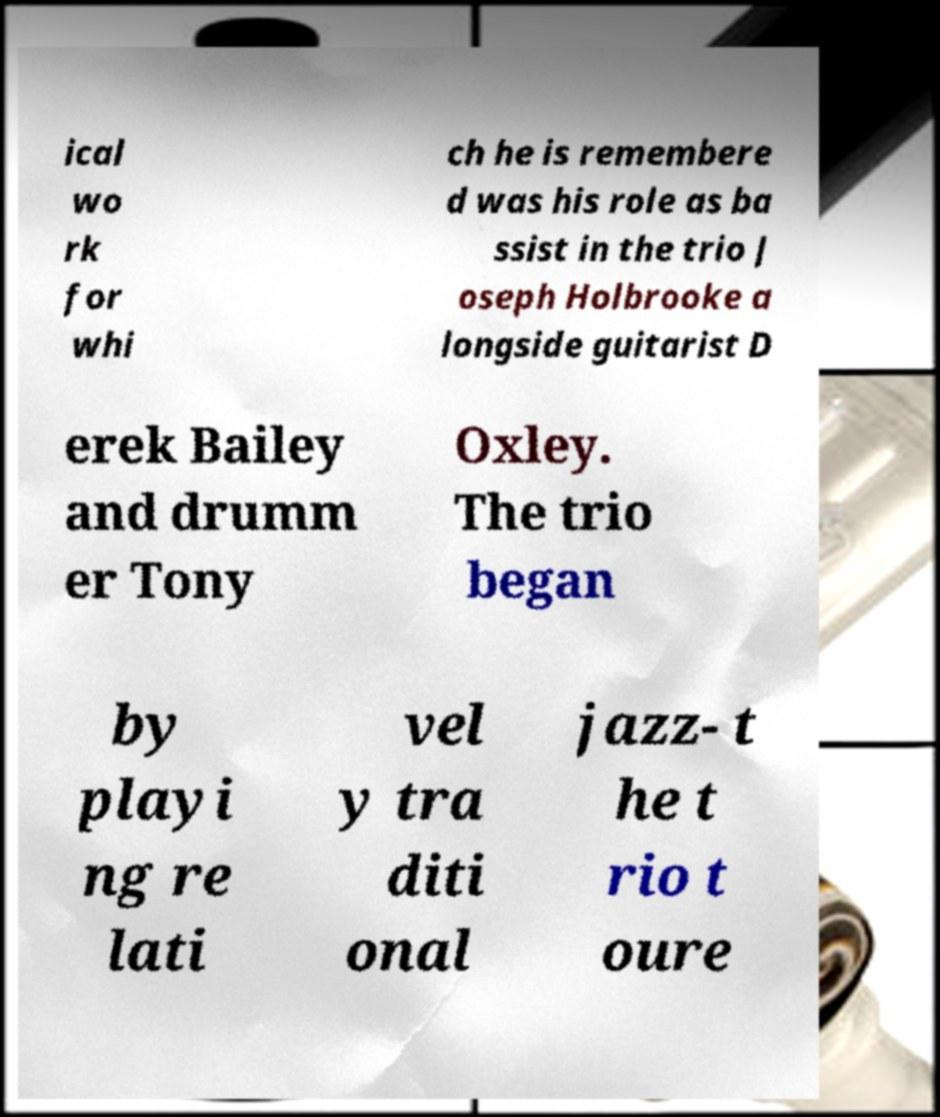For documentation purposes, I need the text within this image transcribed. Could you provide that? ical wo rk for whi ch he is remembere d was his role as ba ssist in the trio J oseph Holbrooke a longside guitarist D erek Bailey and drumm er Tony Oxley. The trio began by playi ng re lati vel y tra diti onal jazz- t he t rio t oure 